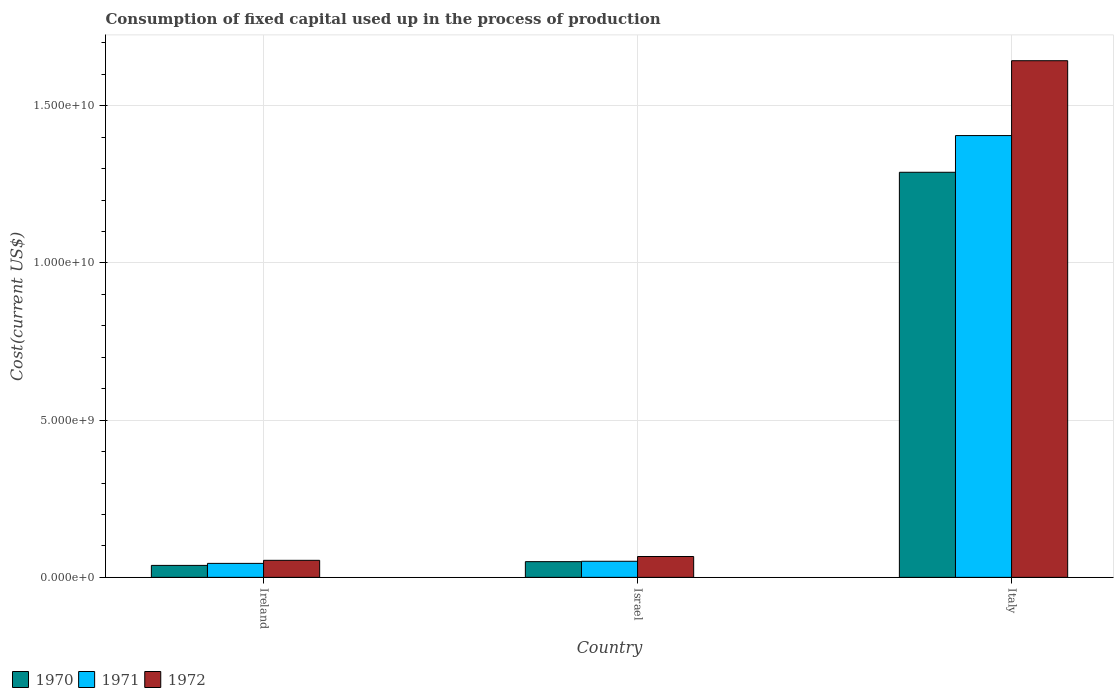Are the number of bars on each tick of the X-axis equal?
Offer a terse response. Yes. How many bars are there on the 3rd tick from the left?
Provide a succinct answer. 3. How many bars are there on the 2nd tick from the right?
Keep it short and to the point. 3. What is the amount consumed in the process of production in 1971 in Ireland?
Your answer should be compact. 4.45e+08. Across all countries, what is the maximum amount consumed in the process of production in 1972?
Your response must be concise. 1.64e+1. Across all countries, what is the minimum amount consumed in the process of production in 1972?
Ensure brevity in your answer.  5.42e+08. In which country was the amount consumed in the process of production in 1970 minimum?
Keep it short and to the point. Ireland. What is the total amount consumed in the process of production in 1972 in the graph?
Your answer should be compact. 1.76e+1. What is the difference between the amount consumed in the process of production in 1971 in Ireland and that in Israel?
Your answer should be very brief. -6.70e+07. What is the difference between the amount consumed in the process of production in 1970 in Israel and the amount consumed in the process of production in 1971 in Ireland?
Your response must be concise. 5.52e+07. What is the average amount consumed in the process of production in 1970 per country?
Make the answer very short. 4.59e+09. What is the difference between the amount consumed in the process of production of/in 1971 and amount consumed in the process of production of/in 1972 in Ireland?
Provide a succinct answer. -9.75e+07. What is the ratio of the amount consumed in the process of production in 1971 in Ireland to that in Israel?
Give a very brief answer. 0.87. Is the difference between the amount consumed in the process of production in 1971 in Israel and Italy greater than the difference between the amount consumed in the process of production in 1972 in Israel and Italy?
Offer a terse response. Yes. What is the difference between the highest and the second highest amount consumed in the process of production in 1970?
Keep it short and to the point. 1.24e+1. What is the difference between the highest and the lowest amount consumed in the process of production in 1971?
Your answer should be compact. 1.36e+1. Is the sum of the amount consumed in the process of production in 1972 in Ireland and Israel greater than the maximum amount consumed in the process of production in 1970 across all countries?
Offer a terse response. No. What does the 3rd bar from the left in Israel represents?
Your response must be concise. 1972. How many bars are there?
Provide a short and direct response. 9. How many countries are there in the graph?
Keep it short and to the point. 3. What is the difference between two consecutive major ticks on the Y-axis?
Ensure brevity in your answer.  5.00e+09. Are the values on the major ticks of Y-axis written in scientific E-notation?
Offer a terse response. Yes. Does the graph contain any zero values?
Provide a short and direct response. No. Does the graph contain grids?
Provide a short and direct response. Yes. Where does the legend appear in the graph?
Give a very brief answer. Bottom left. How many legend labels are there?
Ensure brevity in your answer.  3. What is the title of the graph?
Keep it short and to the point. Consumption of fixed capital used up in the process of production. What is the label or title of the Y-axis?
Provide a succinct answer. Cost(current US$). What is the Cost(current US$) in 1970 in Ireland?
Provide a succinct answer. 3.81e+08. What is the Cost(current US$) of 1971 in Ireland?
Make the answer very short. 4.45e+08. What is the Cost(current US$) in 1972 in Ireland?
Offer a very short reply. 5.42e+08. What is the Cost(current US$) in 1970 in Israel?
Provide a succinct answer. 5.00e+08. What is the Cost(current US$) in 1971 in Israel?
Provide a succinct answer. 5.12e+08. What is the Cost(current US$) of 1972 in Israel?
Ensure brevity in your answer.  6.63e+08. What is the Cost(current US$) of 1970 in Italy?
Your response must be concise. 1.29e+1. What is the Cost(current US$) of 1971 in Italy?
Offer a very short reply. 1.41e+1. What is the Cost(current US$) of 1972 in Italy?
Ensure brevity in your answer.  1.64e+1. Across all countries, what is the maximum Cost(current US$) in 1970?
Offer a very short reply. 1.29e+1. Across all countries, what is the maximum Cost(current US$) of 1971?
Keep it short and to the point. 1.41e+1. Across all countries, what is the maximum Cost(current US$) in 1972?
Provide a succinct answer. 1.64e+1. Across all countries, what is the minimum Cost(current US$) of 1970?
Make the answer very short. 3.81e+08. Across all countries, what is the minimum Cost(current US$) of 1971?
Your response must be concise. 4.45e+08. Across all countries, what is the minimum Cost(current US$) in 1972?
Your answer should be very brief. 5.42e+08. What is the total Cost(current US$) in 1970 in the graph?
Offer a very short reply. 1.38e+1. What is the total Cost(current US$) in 1971 in the graph?
Give a very brief answer. 1.50e+1. What is the total Cost(current US$) of 1972 in the graph?
Ensure brevity in your answer.  1.76e+1. What is the difference between the Cost(current US$) of 1970 in Ireland and that in Israel?
Your answer should be very brief. -1.19e+08. What is the difference between the Cost(current US$) of 1971 in Ireland and that in Israel?
Offer a very short reply. -6.70e+07. What is the difference between the Cost(current US$) of 1972 in Ireland and that in Israel?
Offer a very short reply. -1.21e+08. What is the difference between the Cost(current US$) of 1970 in Ireland and that in Italy?
Provide a succinct answer. -1.25e+1. What is the difference between the Cost(current US$) of 1971 in Ireland and that in Italy?
Make the answer very short. -1.36e+1. What is the difference between the Cost(current US$) in 1972 in Ireland and that in Italy?
Keep it short and to the point. -1.59e+1. What is the difference between the Cost(current US$) in 1970 in Israel and that in Italy?
Ensure brevity in your answer.  -1.24e+1. What is the difference between the Cost(current US$) of 1971 in Israel and that in Italy?
Make the answer very short. -1.35e+1. What is the difference between the Cost(current US$) of 1972 in Israel and that in Italy?
Keep it short and to the point. -1.58e+1. What is the difference between the Cost(current US$) in 1970 in Ireland and the Cost(current US$) in 1971 in Israel?
Make the answer very short. -1.31e+08. What is the difference between the Cost(current US$) in 1970 in Ireland and the Cost(current US$) in 1972 in Israel?
Provide a succinct answer. -2.83e+08. What is the difference between the Cost(current US$) in 1971 in Ireland and the Cost(current US$) in 1972 in Israel?
Provide a succinct answer. -2.19e+08. What is the difference between the Cost(current US$) in 1970 in Ireland and the Cost(current US$) in 1971 in Italy?
Your response must be concise. -1.37e+1. What is the difference between the Cost(current US$) of 1970 in Ireland and the Cost(current US$) of 1972 in Italy?
Keep it short and to the point. -1.61e+1. What is the difference between the Cost(current US$) in 1971 in Ireland and the Cost(current US$) in 1972 in Italy?
Give a very brief answer. -1.60e+1. What is the difference between the Cost(current US$) in 1970 in Israel and the Cost(current US$) in 1971 in Italy?
Offer a terse response. -1.36e+1. What is the difference between the Cost(current US$) in 1970 in Israel and the Cost(current US$) in 1972 in Italy?
Make the answer very short. -1.59e+1. What is the difference between the Cost(current US$) in 1971 in Israel and the Cost(current US$) in 1972 in Italy?
Offer a very short reply. -1.59e+1. What is the average Cost(current US$) in 1970 per country?
Provide a succinct answer. 4.59e+09. What is the average Cost(current US$) in 1971 per country?
Make the answer very short. 5.00e+09. What is the average Cost(current US$) in 1972 per country?
Make the answer very short. 5.88e+09. What is the difference between the Cost(current US$) in 1970 and Cost(current US$) in 1971 in Ireland?
Offer a very short reply. -6.40e+07. What is the difference between the Cost(current US$) in 1970 and Cost(current US$) in 1972 in Ireland?
Give a very brief answer. -1.61e+08. What is the difference between the Cost(current US$) in 1971 and Cost(current US$) in 1972 in Ireland?
Offer a terse response. -9.75e+07. What is the difference between the Cost(current US$) of 1970 and Cost(current US$) of 1971 in Israel?
Provide a short and direct response. -1.18e+07. What is the difference between the Cost(current US$) in 1970 and Cost(current US$) in 1972 in Israel?
Offer a very short reply. -1.63e+08. What is the difference between the Cost(current US$) in 1971 and Cost(current US$) in 1972 in Israel?
Make the answer very short. -1.52e+08. What is the difference between the Cost(current US$) in 1970 and Cost(current US$) in 1971 in Italy?
Provide a short and direct response. -1.17e+09. What is the difference between the Cost(current US$) in 1970 and Cost(current US$) in 1972 in Italy?
Provide a short and direct response. -3.55e+09. What is the difference between the Cost(current US$) of 1971 and Cost(current US$) of 1972 in Italy?
Your answer should be very brief. -2.38e+09. What is the ratio of the Cost(current US$) in 1970 in Ireland to that in Israel?
Offer a very short reply. 0.76. What is the ratio of the Cost(current US$) of 1971 in Ireland to that in Israel?
Make the answer very short. 0.87. What is the ratio of the Cost(current US$) of 1972 in Ireland to that in Israel?
Provide a succinct answer. 0.82. What is the ratio of the Cost(current US$) of 1970 in Ireland to that in Italy?
Provide a short and direct response. 0.03. What is the ratio of the Cost(current US$) of 1971 in Ireland to that in Italy?
Ensure brevity in your answer.  0.03. What is the ratio of the Cost(current US$) in 1972 in Ireland to that in Italy?
Make the answer very short. 0.03. What is the ratio of the Cost(current US$) in 1970 in Israel to that in Italy?
Provide a succinct answer. 0.04. What is the ratio of the Cost(current US$) in 1971 in Israel to that in Italy?
Give a very brief answer. 0.04. What is the ratio of the Cost(current US$) of 1972 in Israel to that in Italy?
Provide a short and direct response. 0.04. What is the difference between the highest and the second highest Cost(current US$) in 1970?
Ensure brevity in your answer.  1.24e+1. What is the difference between the highest and the second highest Cost(current US$) in 1971?
Offer a very short reply. 1.35e+1. What is the difference between the highest and the second highest Cost(current US$) in 1972?
Your response must be concise. 1.58e+1. What is the difference between the highest and the lowest Cost(current US$) of 1970?
Keep it short and to the point. 1.25e+1. What is the difference between the highest and the lowest Cost(current US$) in 1971?
Your answer should be very brief. 1.36e+1. What is the difference between the highest and the lowest Cost(current US$) of 1972?
Your answer should be compact. 1.59e+1. 